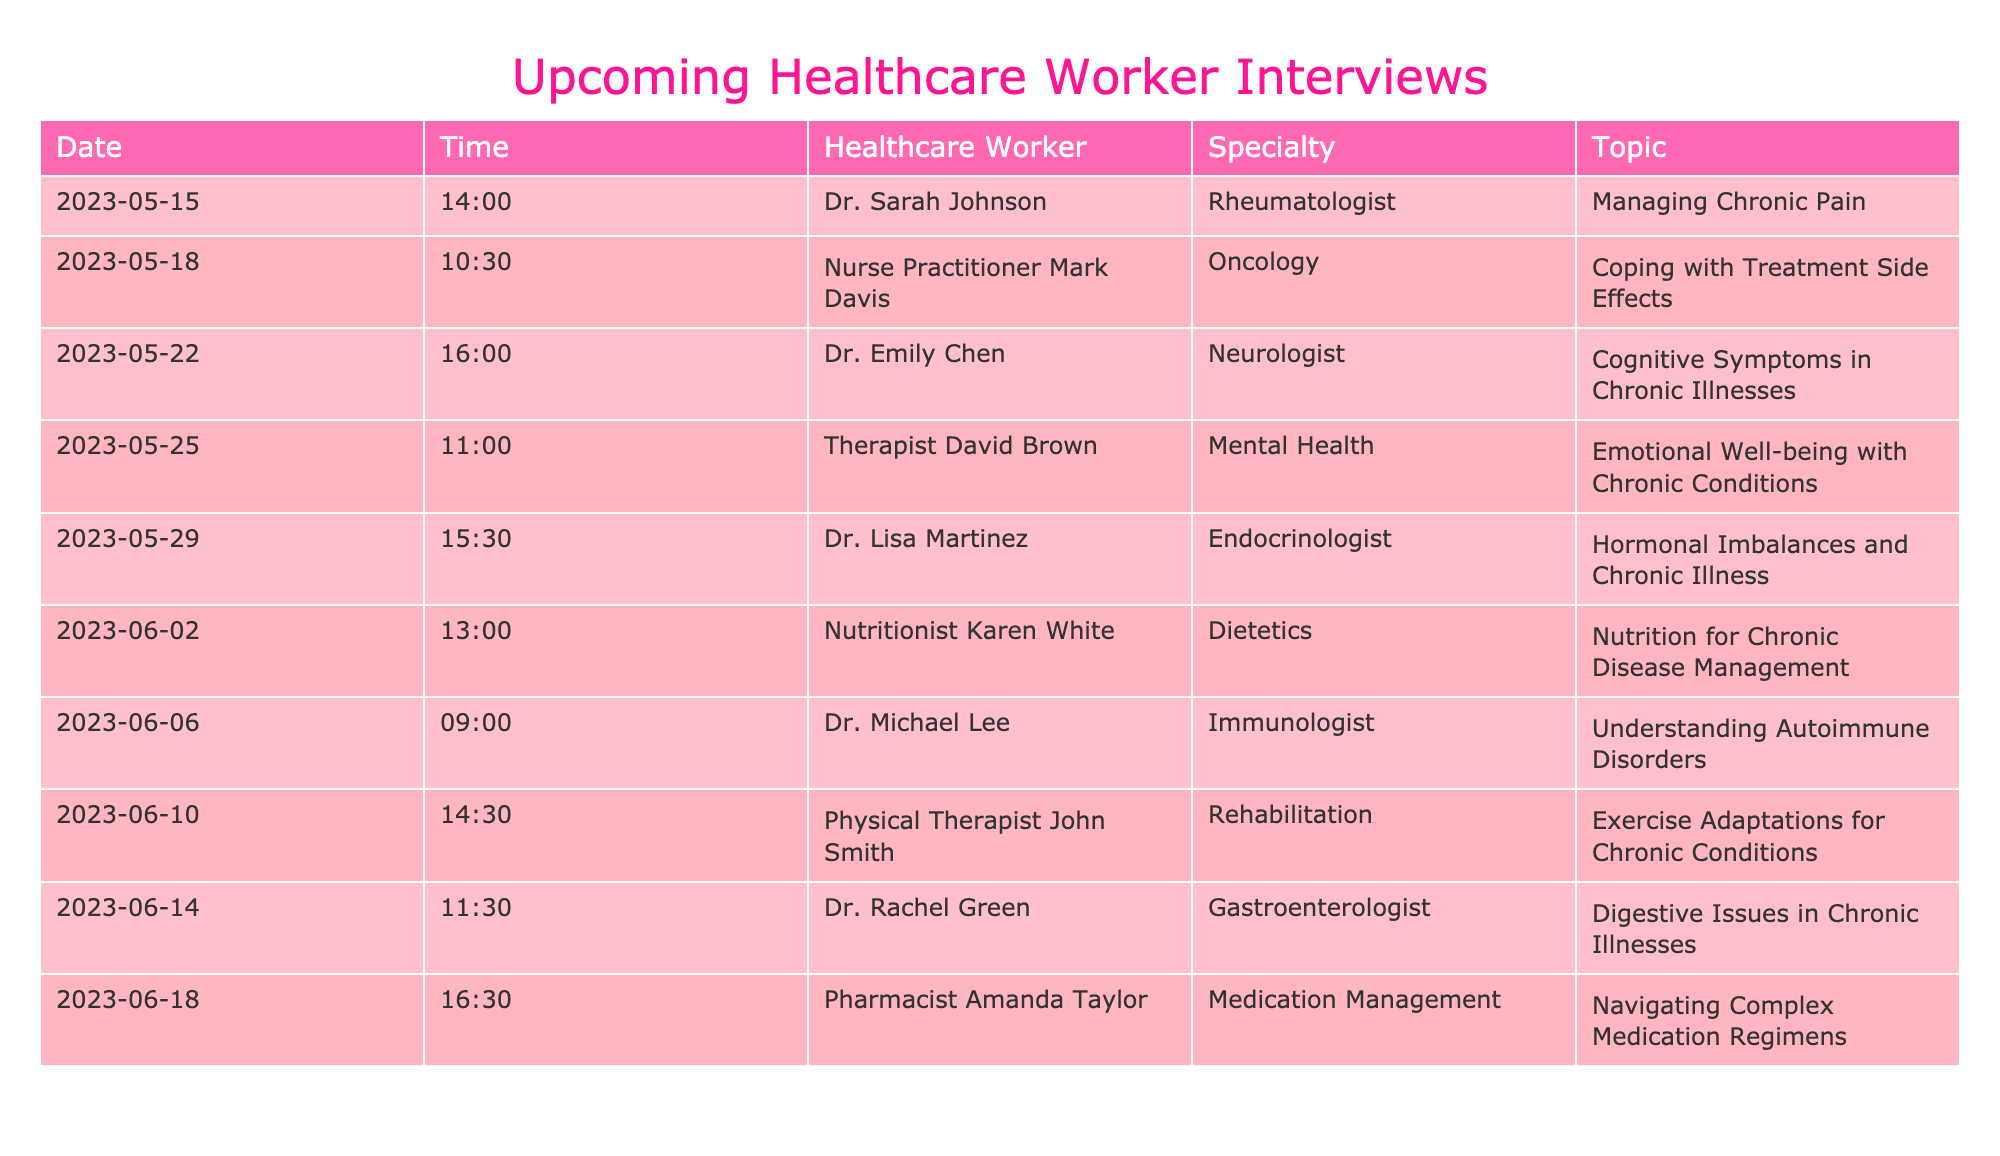What is the specialty of Nurse Practitioner Mark Davis? The table shows Nurse Practitioner Mark Davis is an Oncology specialist. This information can be found directly in the "Healthcare Worker" and "Specialty" columns of the table corresponding to his name.
Answer: Oncology Which healthcare worker will discuss hormonal imbalances? According to the table, Dr. Lisa Martinez, the Endocrinologist, will address hormonal imbalances and chronic illness on May 29. The topic is listed under the "Topic" column for Dr. Martinez.
Answer: Dr. Lisa Martinez How many interviews are scheduled in June? The table lists six interviews scheduled in June, specifically from June 2 to June 18. By counting the entries corresponding to the month of June, we find there are six scheduled interviews.
Answer: 6 Is there an interview focusing on managing chronic pain? Yes, according to the table, Dr. Sarah Johnson is conducting an interview on managing chronic pain on May 15. This topic can be confirmed by checking the "Topic" column next to Dr. Johnson's name.
Answer: Yes Which topic will Dr. Rachel Green cover during her interview? Dr. Rachel Green is set to discuss digestive issues in chronic illnesses on June 14, as indicated in the "Topic" column corresponding to her entry in the table.
Answer: Digestive issues in chronic illnesses On what date are the interviews with the physical therapist and the pharmacist scheduled? The physical therapist, John Smith, is scheduled for June 10, while the pharmacist, Amanda Taylor, is set for June 18. By checking the "Date" column for each person's "Healthcare Worker" entry, we can determine their respective dates.
Answer: June 10 and June 18 What is the time gap between the interviews by Dr. Sarah Johnson and Nurse Practitioner Mark Davis? Dr. Sarah Johnson's interview is on May 15 at 14:00, and Nurse Practitioner Mark Davis's interview is on May 18 at 10:30. Calculating the time gap involves finding the difference between the two dates and times. Between the two, there is a gap of 2 days and 20.5 hours (from May 15 at 14:00 to May 18 at 10:30).
Answer: 2 days and 20.5 hours Which specialty is not represented in the month of June? By examining the specialties scheduled for interviews in June, we can see that Rheumatology is not represented. The specialties available in June include Neurology, Mental Health, Endocrinology, Dietetics, Immunology, Rehabilitation, and Gastroenterology.
Answer: Rheumatology 